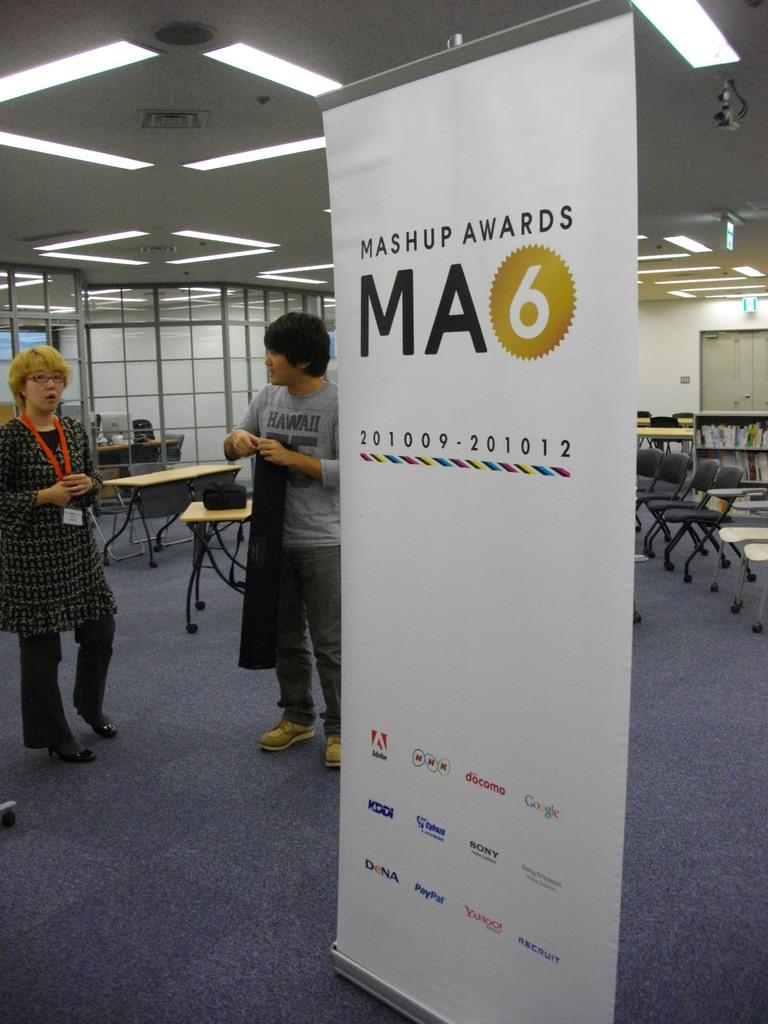How many people are in the image? There is a man and a woman standing in the image. What can be seen hanging in the image? There is a banner in the image. What type of furniture is present in the image? There are chairs, a rack, tables, and books in the image. What can be seen in the background of the image? In the background, there are glasses, lights, boards, a door, and a wall. Can you see an owl perched on the rack in the image? No, there is no owl present in the image. How does the ship in the image navigate through the room? There is no ship present in the image. 